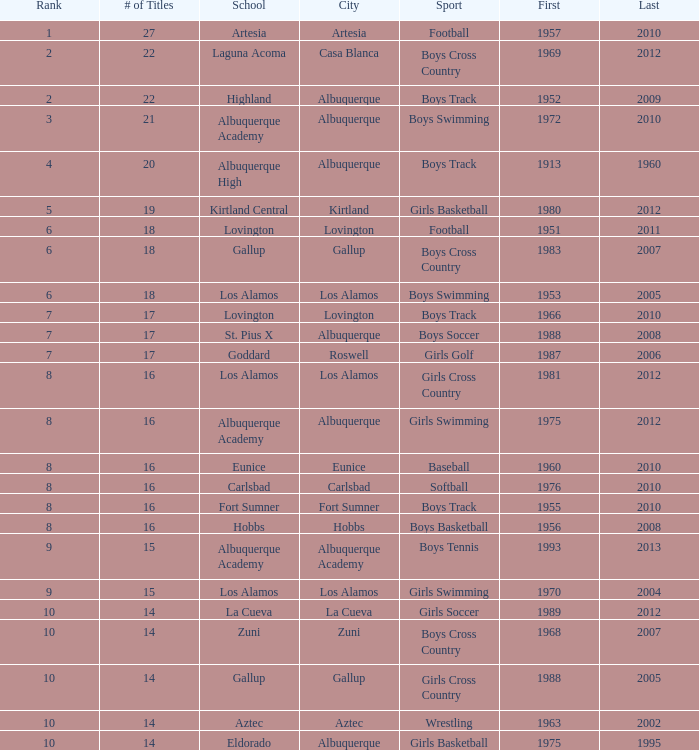What is the top position for the boys swimming team in albuquerque? 3.0. 